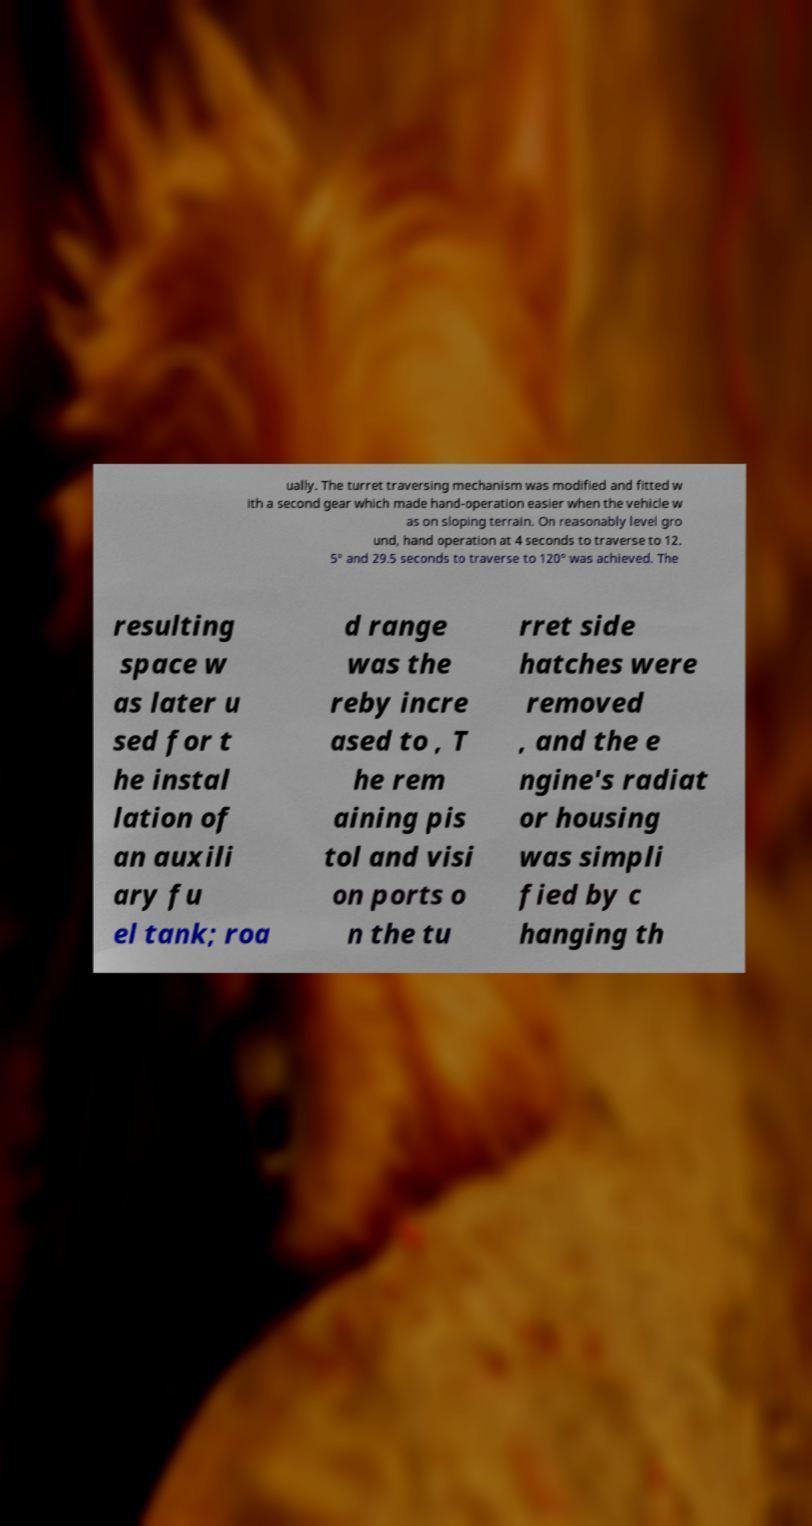I need the written content from this picture converted into text. Can you do that? ually. The turret traversing mechanism was modified and fitted w ith a second gear which made hand-operation easier when the vehicle w as on sloping terrain. On reasonably level gro und, hand operation at 4 seconds to traverse to 12. 5° and 29.5 seconds to traverse to 120° was achieved. The resulting space w as later u sed for t he instal lation of an auxili ary fu el tank; roa d range was the reby incre ased to , T he rem aining pis tol and visi on ports o n the tu rret side hatches were removed , and the e ngine's radiat or housing was simpli fied by c hanging th 